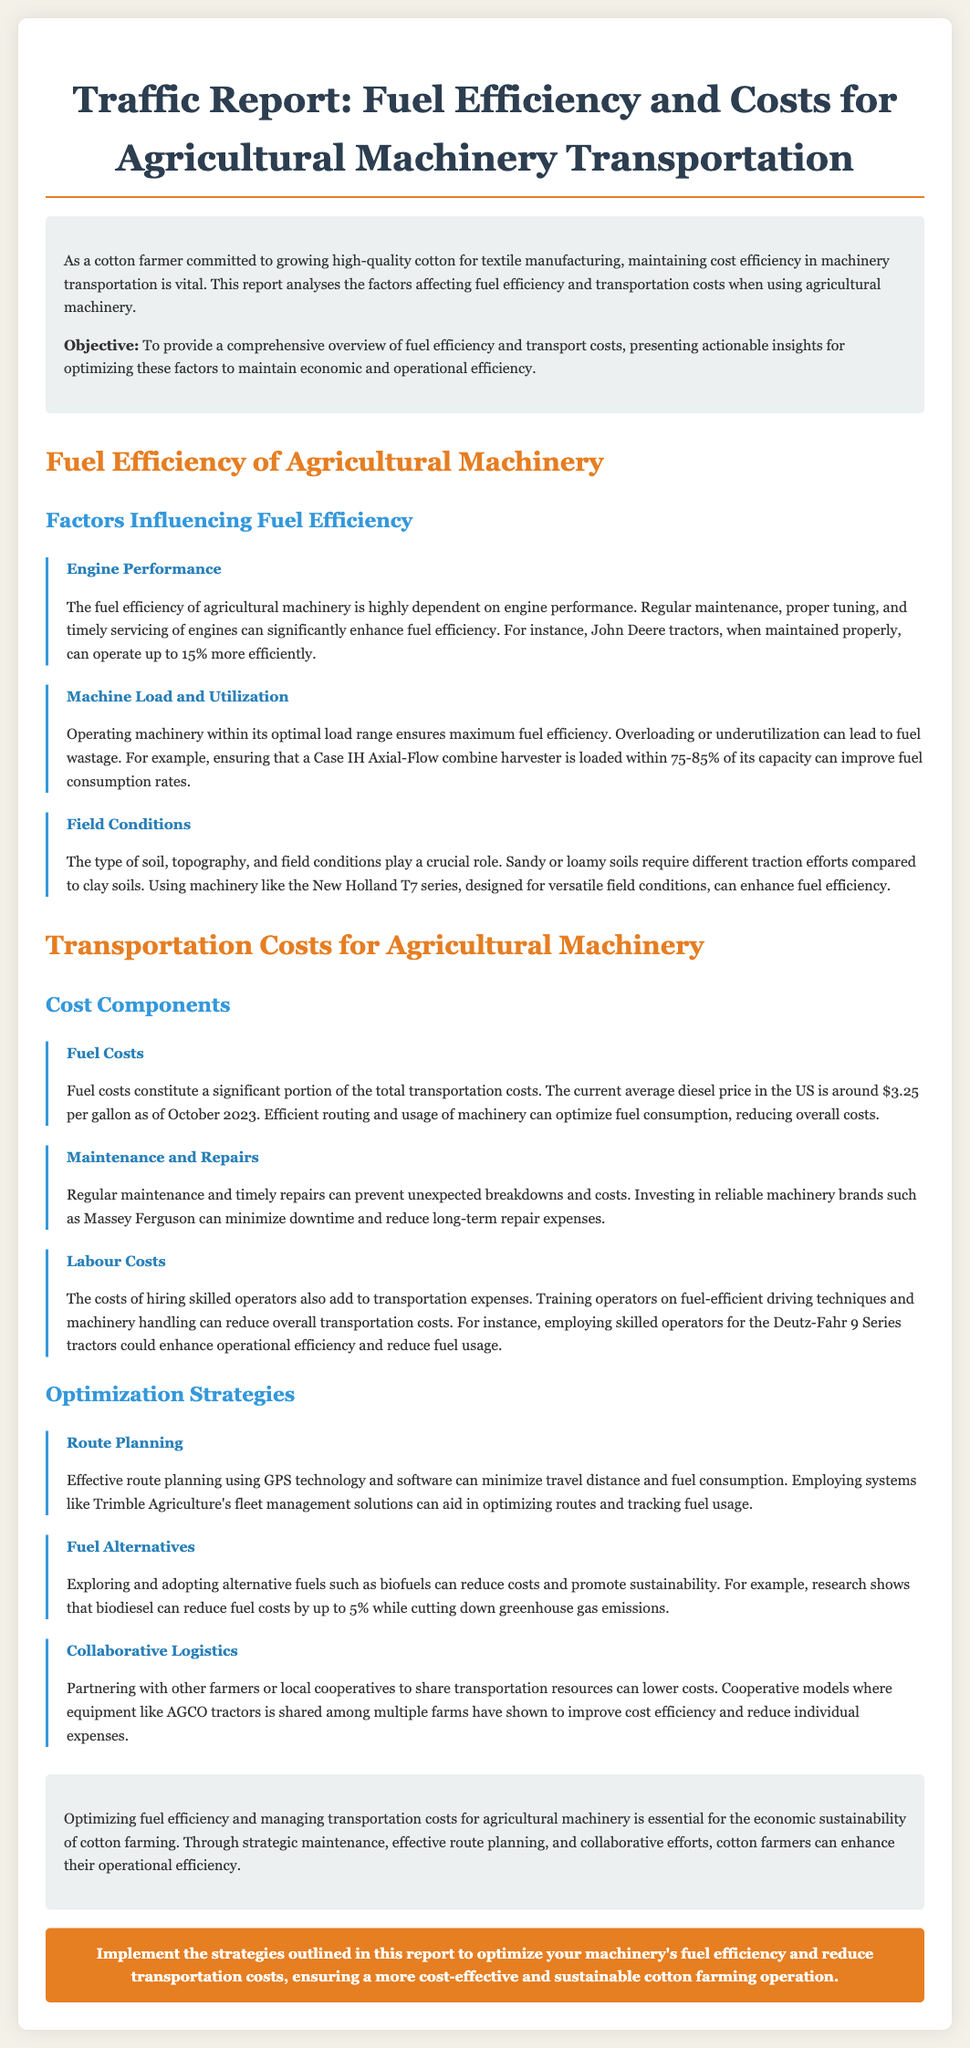what is the average diesel price in the US as of October 2023? The report states that the current average diesel price is around $3.25 per gallon.
Answer: $3.25 per gallon how much more efficiently can John Deere tractors operate when maintained properly? It is mentioned that John Deere tractors can operate up to 15% more efficiently.
Answer: 15% what can improve fuel consumption rates for a Case IH Axial-Flow combine harvester? Operating the combine harvester within 75-85% of its capacity can improve fuel consumption rates.
Answer: 75-85% what technology can aid in effective route planning? The report suggests employing GPS technology and software for effective route planning.
Answer: GPS technology how can biodiesel impact fuel costs? Research shows that biodiesel can reduce fuel costs by up to 5%.
Answer: 5% what is a vital factor for economic sustainability in cotton farming? The document emphasizes that optimizing fuel efficiency and managing transportation costs is essential for economic sustainability.
Answer: optimizing fuel efficiency and managing transportation costs what regular action can prevent unexpected breakdowns in machinery? Regular maintenance can prevent unexpected breakdowns and costs.
Answer: Regular maintenance what is one strategy for lowering transportation costs through collaboration? Partnering with other farmers or local cooperatives to share transportation resources can lower costs.
Answer: sharing transportation resources 